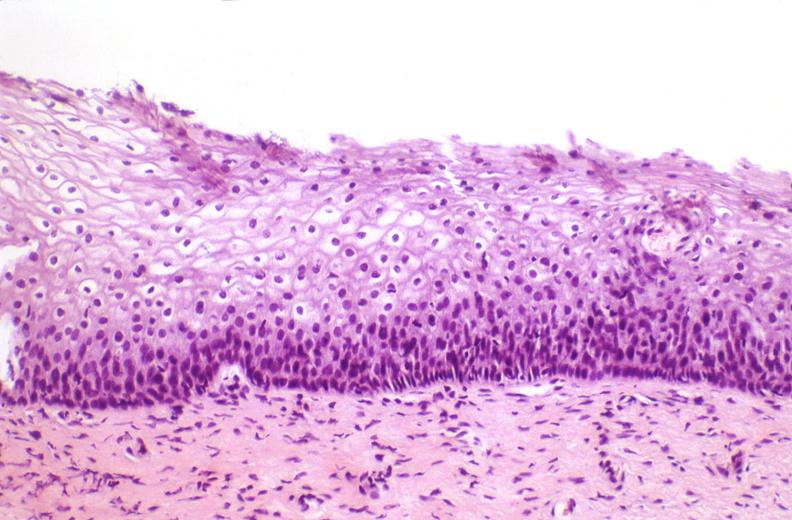does this image show cervix, mild dysplasia?
Answer the question using a single word or phrase. Yes 